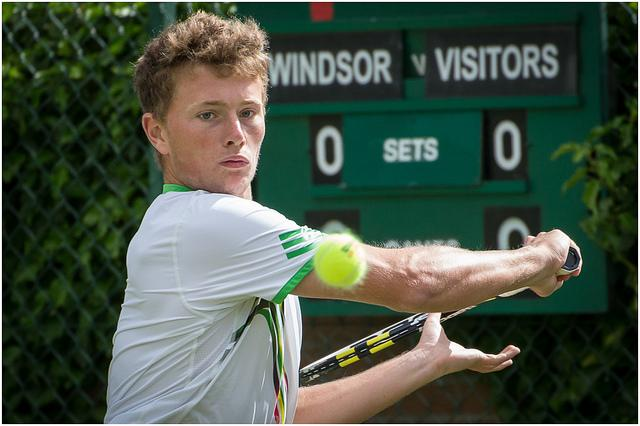Someone needs to score at least how many sets to win?

Choices:
A) four
B) five
C) two
D) eight two 